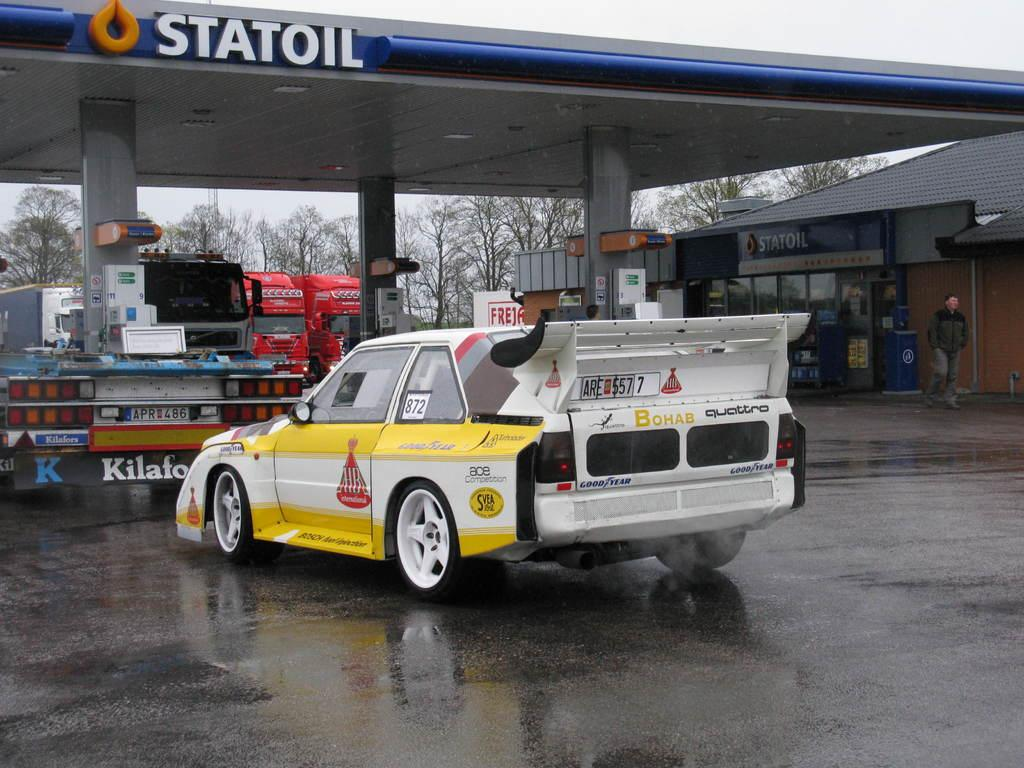What is on the road in the image? There is a vehicle on the road in the image. What is the person in the image doing? There is a person walking in the image. What can be seen near the road in the image? There is an oil bunk in the image. What type of establishment is visible in the image? There is a store in the image. What can be seen in the distance in the image? There are vehicles and trees visible in the background, and the sky is also visible in the background. What type of suit is the ant wearing in the image? There is no ant or suit present in the image. What force is being applied to the vehicles in the background? There is no indication of any force being applied to the vehicles in the background; they are simply parked or driving. 